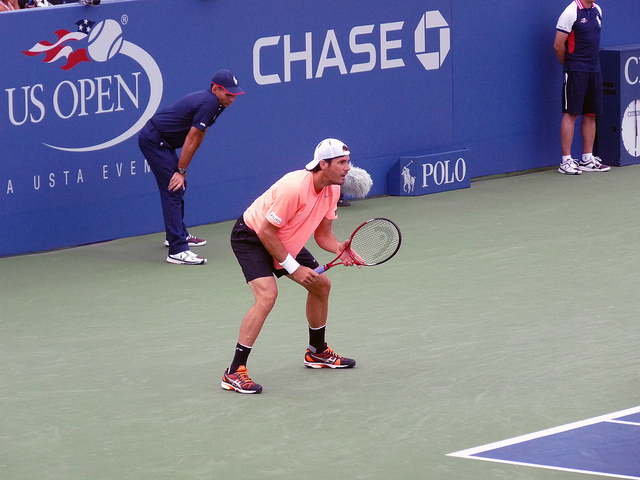Identify the text contained in this image. POLO CHASE US OPEN USTA R A EVEN C 